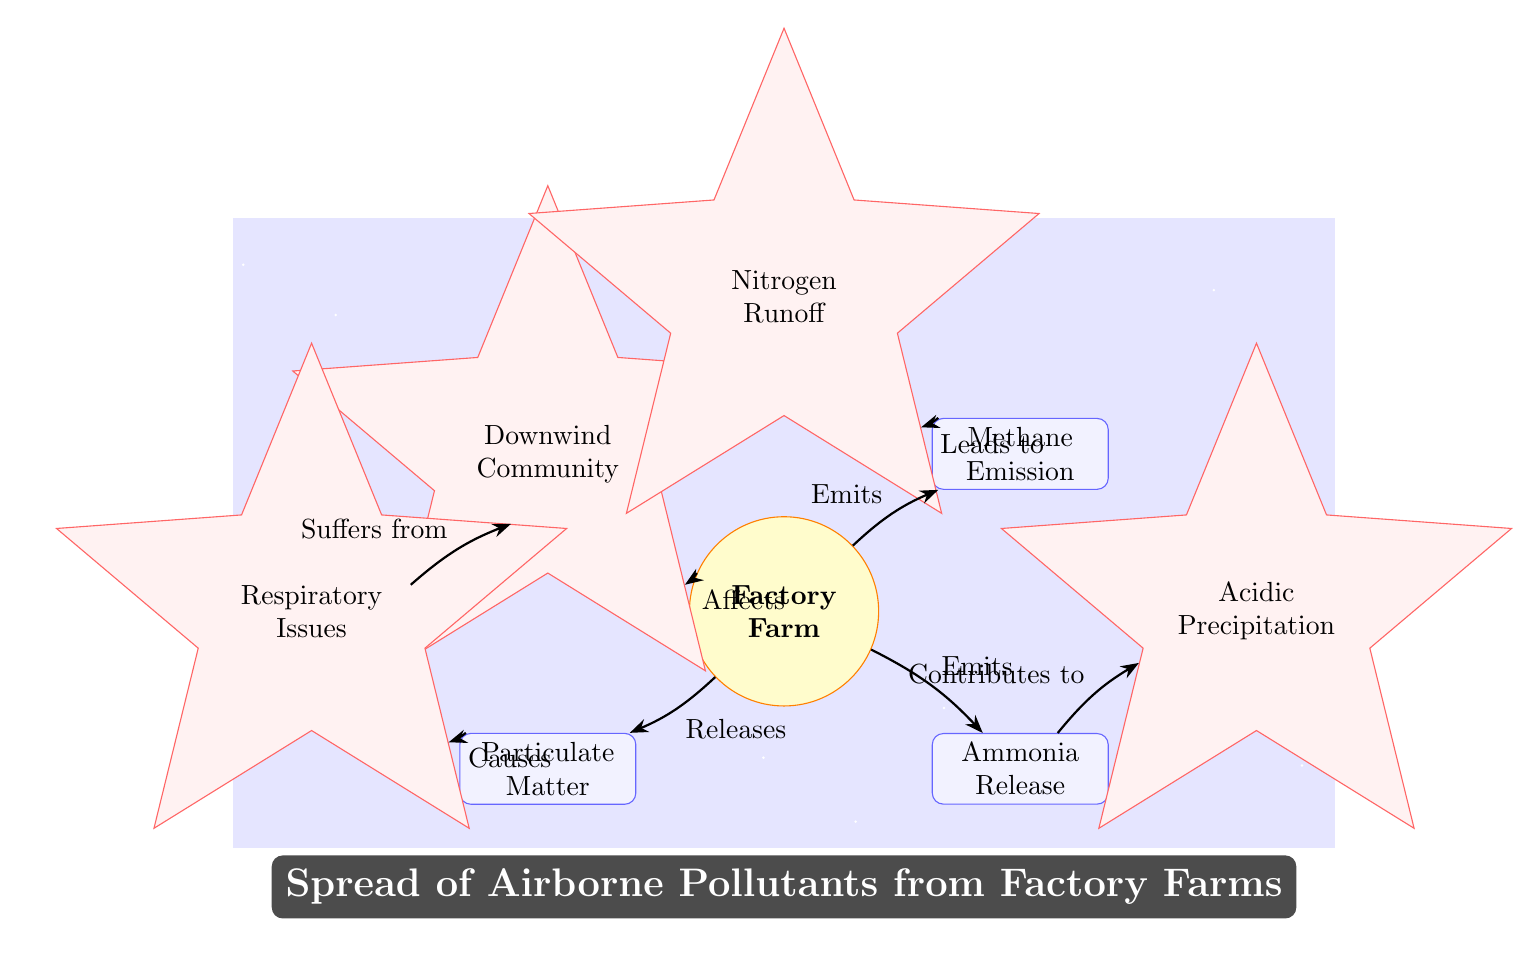What is emitted by the factory farm? The diagram indicates two pollutants being emitted from the factory farm, which are ammonia and methane. Both are listed as 'Emits' connections from the factory farm node.
Answer: Ammonia, Methane What does the particulate matter cause? Particulate matter is shown in the diagram as causing respiratory issues. This connection is depicted through the 'Causes' relationship from the particulate matter box to the respiratory issues box.
Answer: Respiratory Issues How many impact nodes are in the diagram? By counting the star-shaped impact nodes, we see four: downwind community, respiratory issues, acidic precipitation, and nitrogen runoff.
Answer: 4 What contributes to acidic precipitation? The diagram explicitly states that ammonia release contributes to acidic precipitation, indicated by the 'Contributes to' connection from the ammonia release node to the acidic precipitation node.
Answer: Ammonia Release If downwind communities are affected, what issues do they suffer from? The diagram shows that downwind communities suffer from respiratory issues, indicated by the 'Suffers from' connection directly from the downwind community node to the respiratory issues node.
Answer: Respiratory Issues How does methane emission lead to nitrogen runoff? The connection shows that the arrow from methane emission leads directly to nitrogen runoff. The relationship indicates the directional flow from one component to another in the context of environmental impact.
Answer: Leads to Nitrogen Runoff Which node represents the initial source of pollution? The factory farm node represents the initial source of pollution, as it is the starting point from which all emissions and subsequent effects flow from.
Answer: Factory Farm What relationship exists between ammonia release and the factory farm? The diagram clearly shows that ammonia is emitted from the factory farm, represented by an 'Emits' connection from the factory farm to ammonia release.
Answer: Emits 